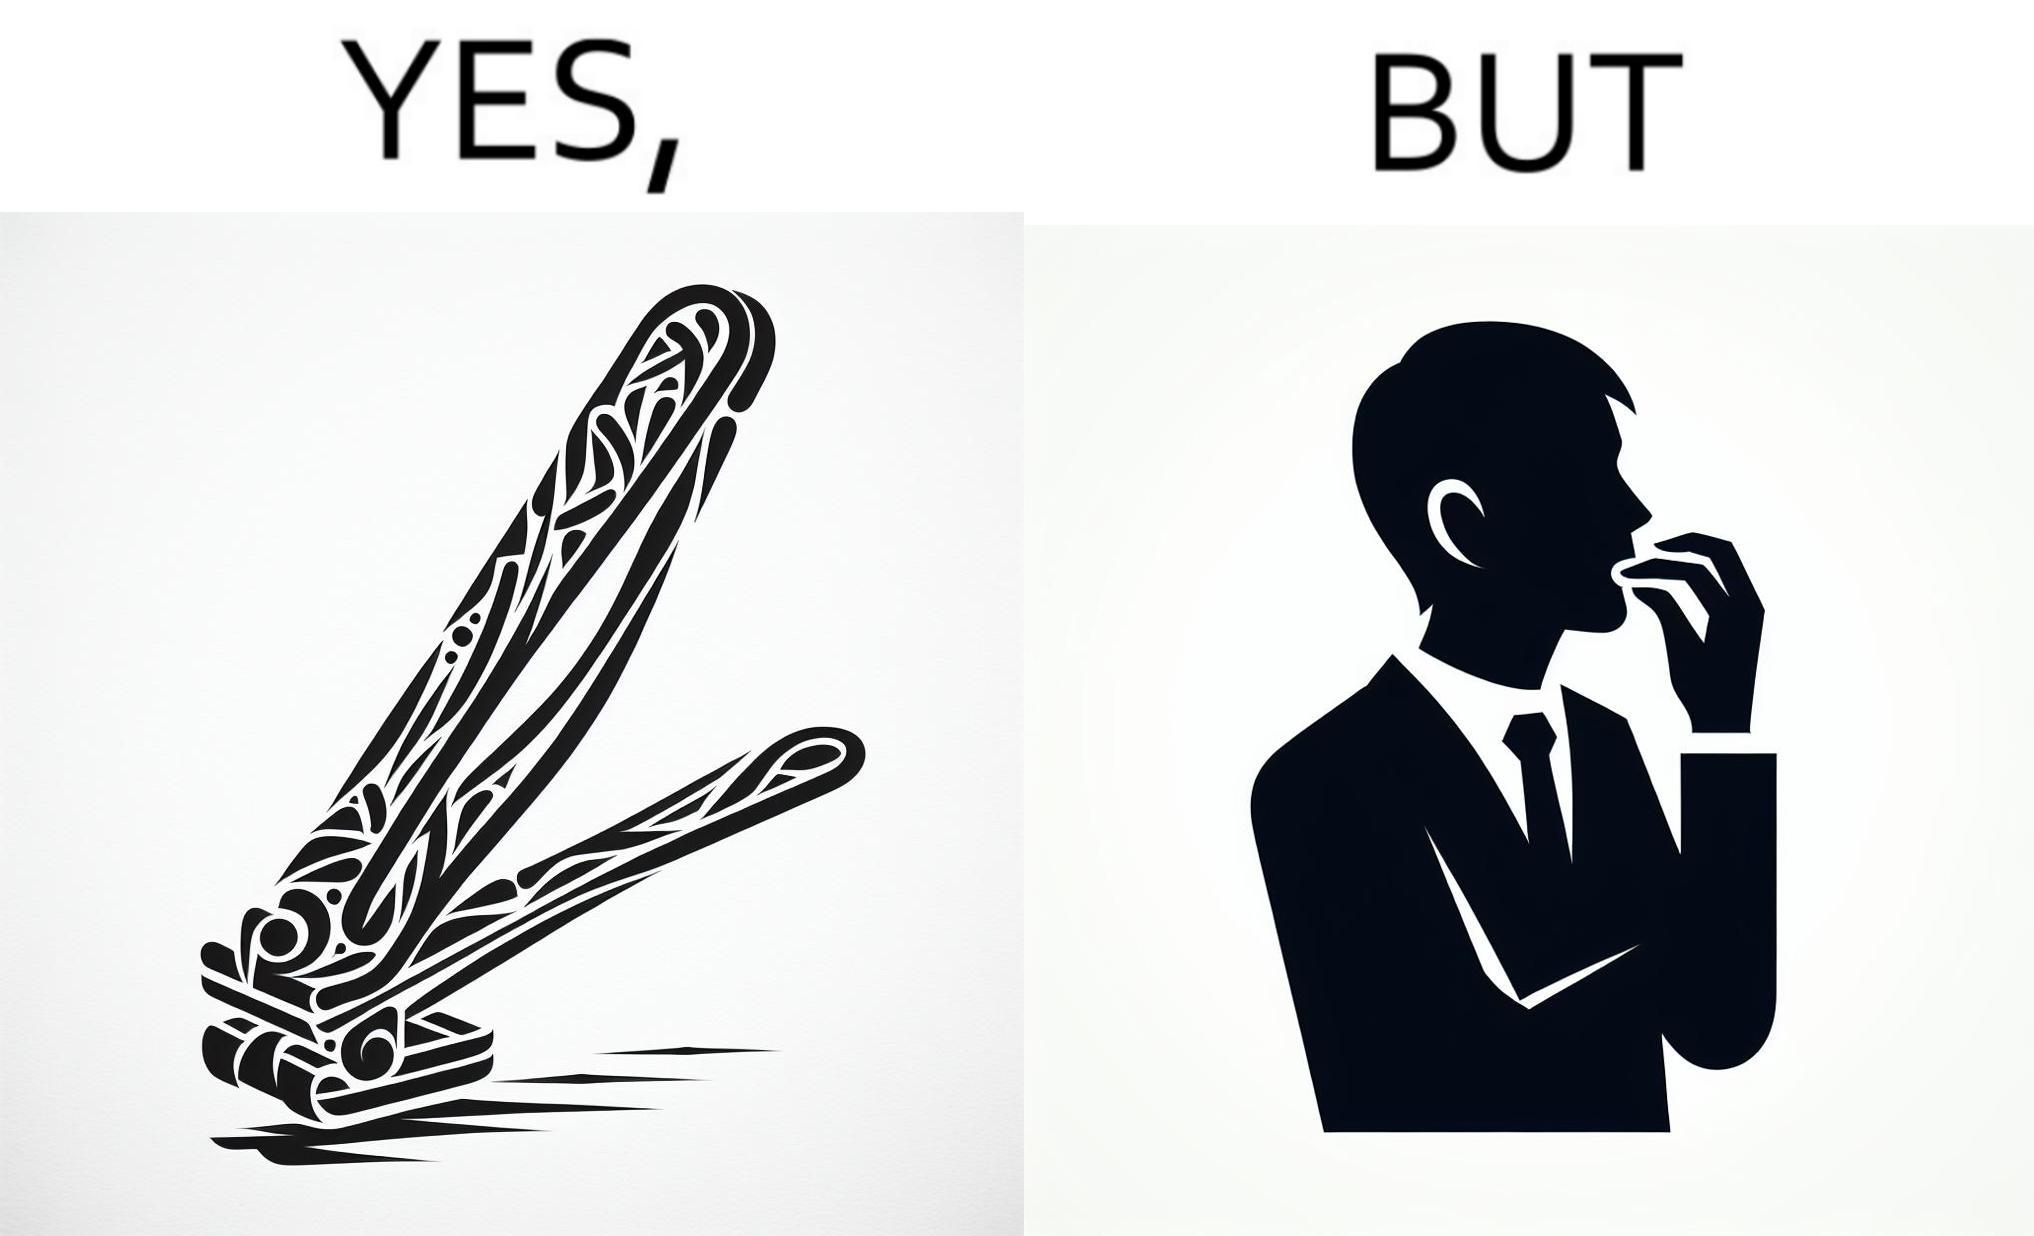Provide a description of this image. The image is ironic, because even after nail clippers are available people prefer biting their nails by teeth 